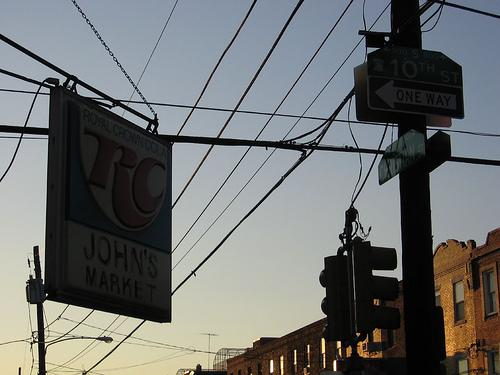Question: where is the balcony?
Choices:
A. Above the door.
B. There isn't one.
C. Over the patio.
D. Under the moonlight.
Answer with the letter. Answer: B Question: what is the man doing?
Choices:
A. No man.
B. Standing.
C. Running.
D. Jumping.
Answer with the letter. Answer: A 